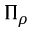<formula> <loc_0><loc_0><loc_500><loc_500>\Pi _ { \rho }</formula> 